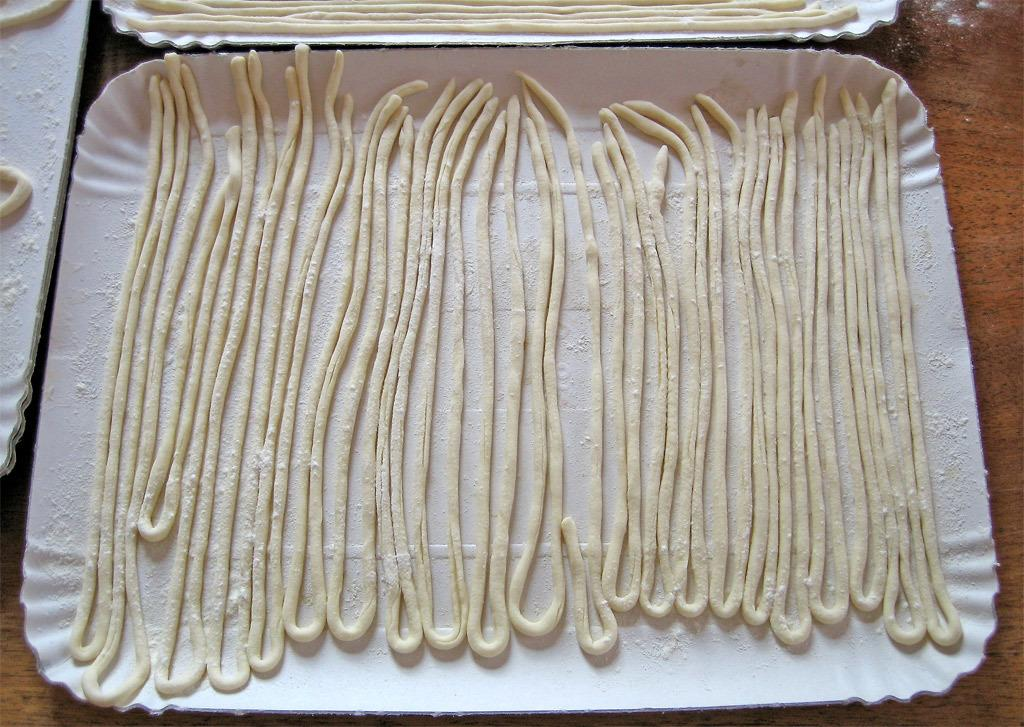What type of art supplies are in the image? There are thick hand rolled pastels in the image. How are the pastels arranged? The pastels are arranged on white color plates. What is the surface on which the plates are placed? The plates are on a wooden table. Can you tell me how many people are resting on the sofa in the image? There is no sofa present in the image; it features thick hand rolled pastels arranged on white color plates on a wooden table. 